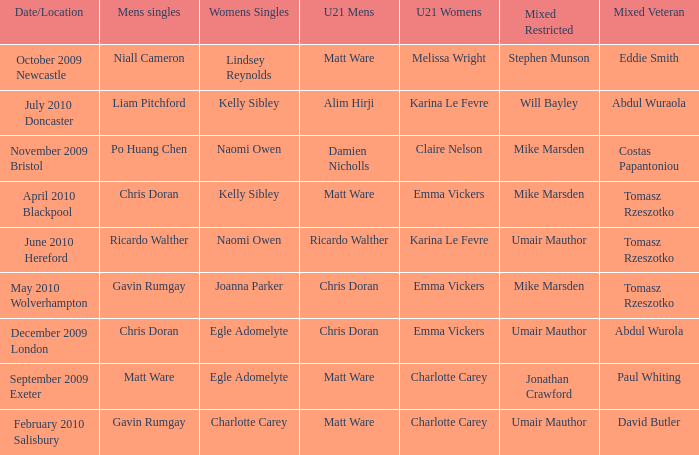When Matt Ware won the mens singles, who won the mixed restricted? Jonathan Crawford. 